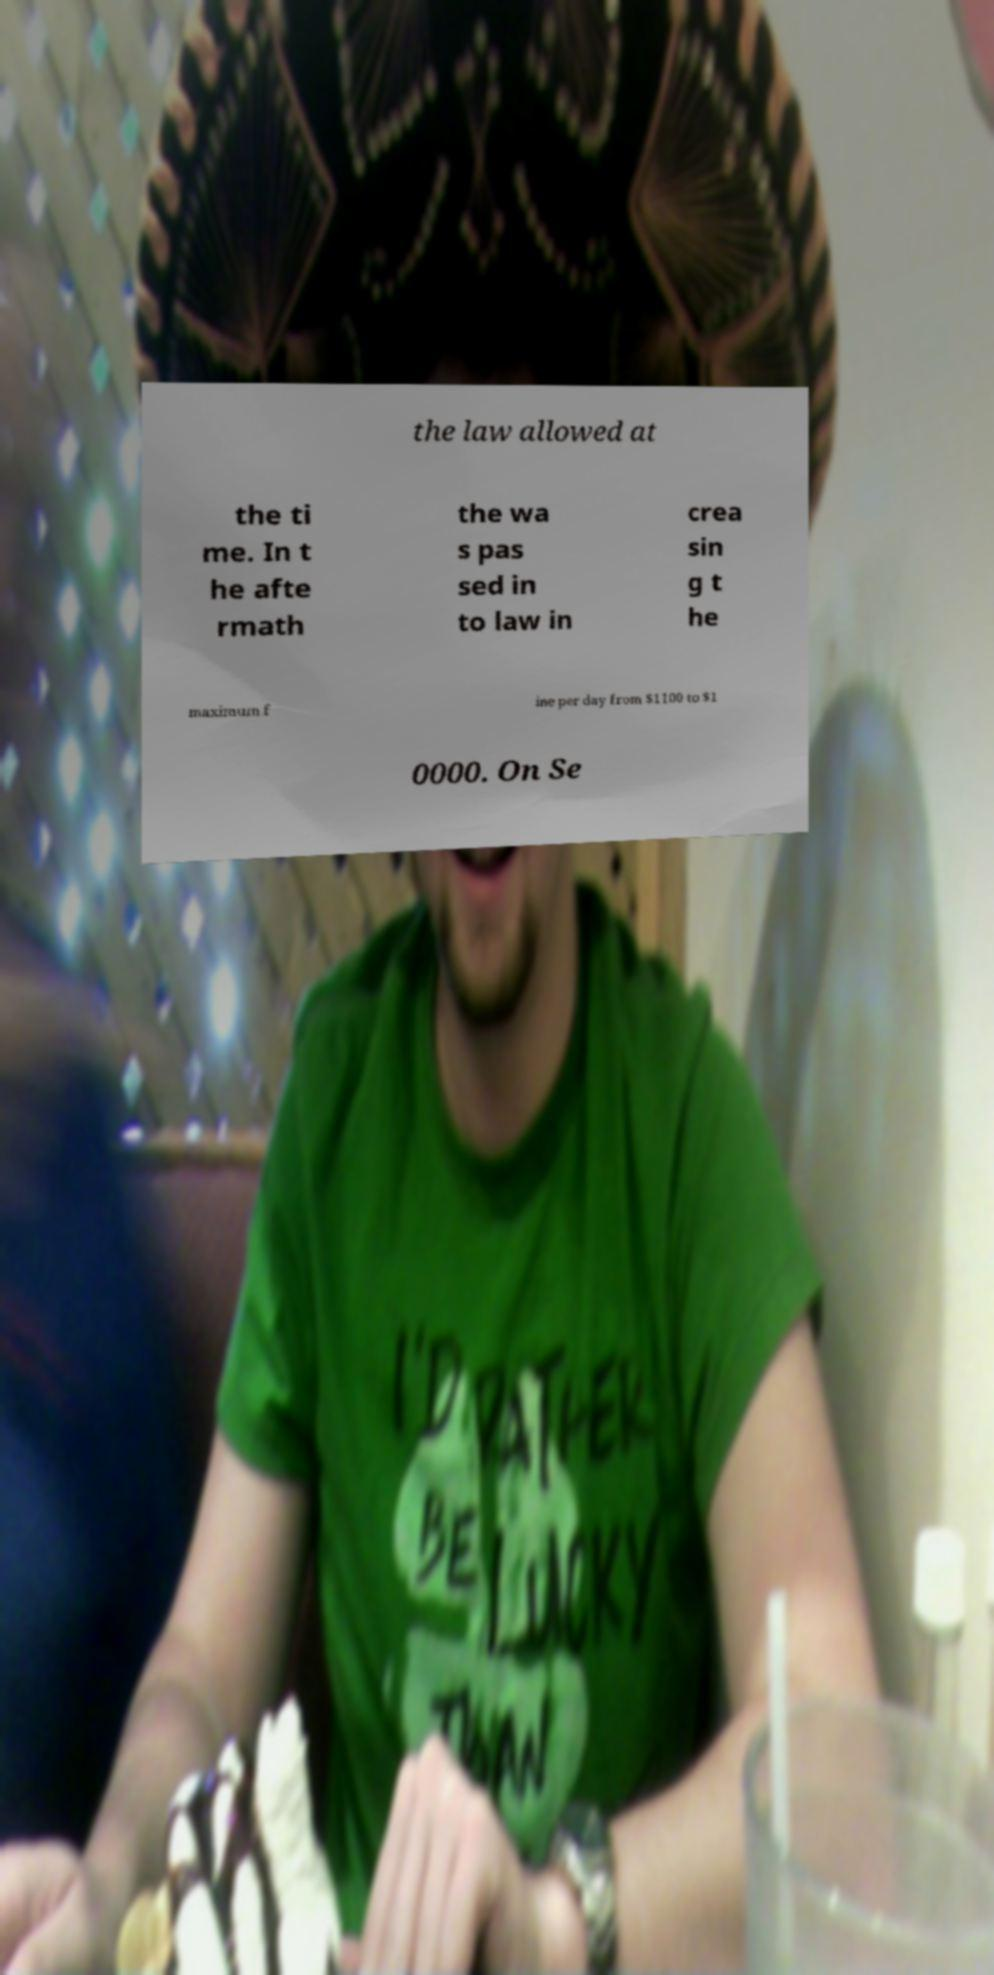Please identify and transcribe the text found in this image. the law allowed at the ti me. In t he afte rmath the wa s pas sed in to law in crea sin g t he maximum f ine per day from $1100 to $1 0000. On Se 